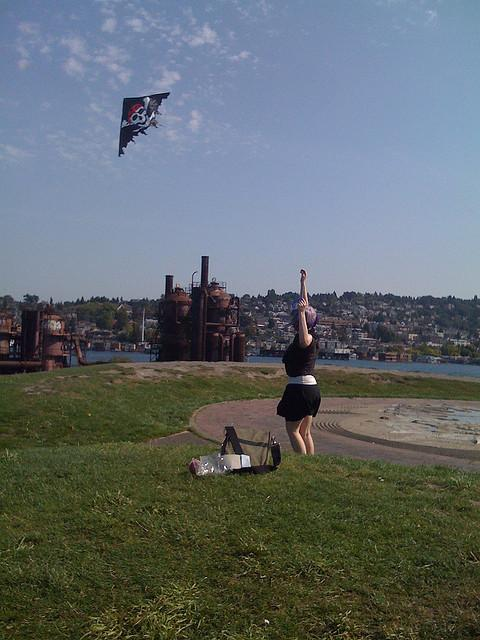How does the woman direct here kite and control it? Please explain your reasoning. string. This is attached to the kite 